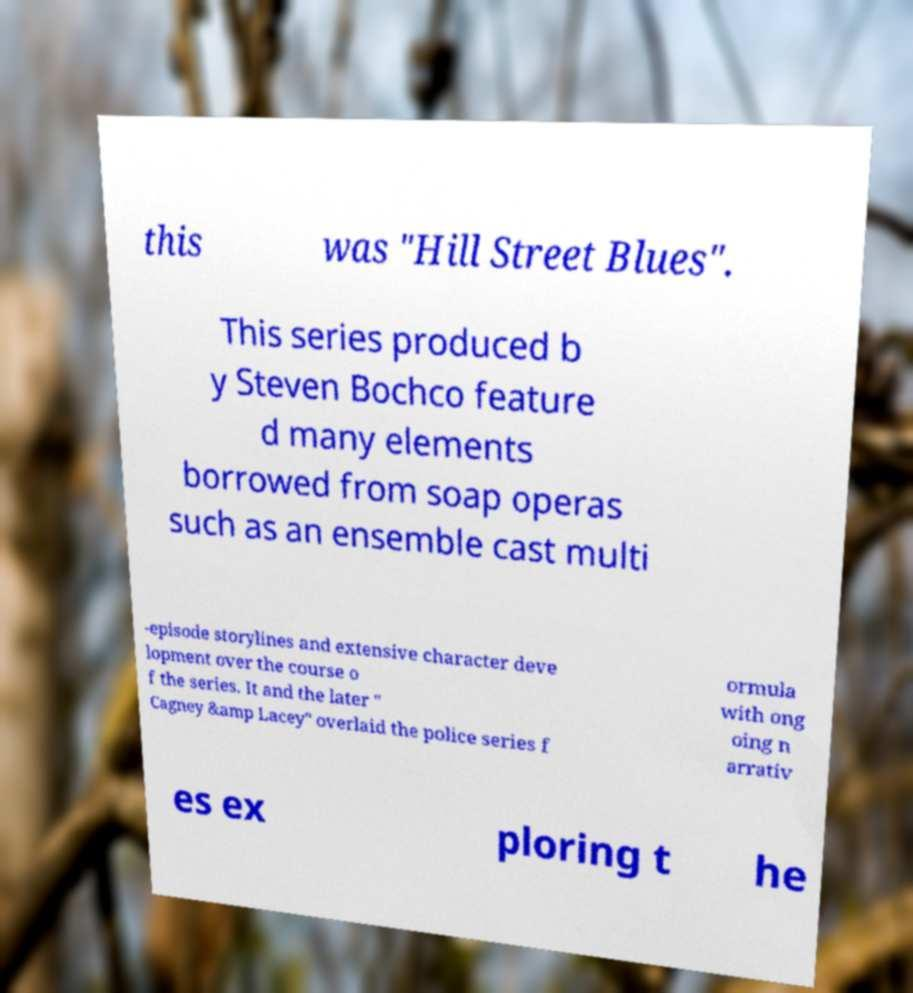I need the written content from this picture converted into text. Can you do that? this was "Hill Street Blues". This series produced b y Steven Bochco feature d many elements borrowed from soap operas such as an ensemble cast multi -episode storylines and extensive character deve lopment over the course o f the series. It and the later " Cagney &amp Lacey" overlaid the police series f ormula with ong oing n arrativ es ex ploring t he 